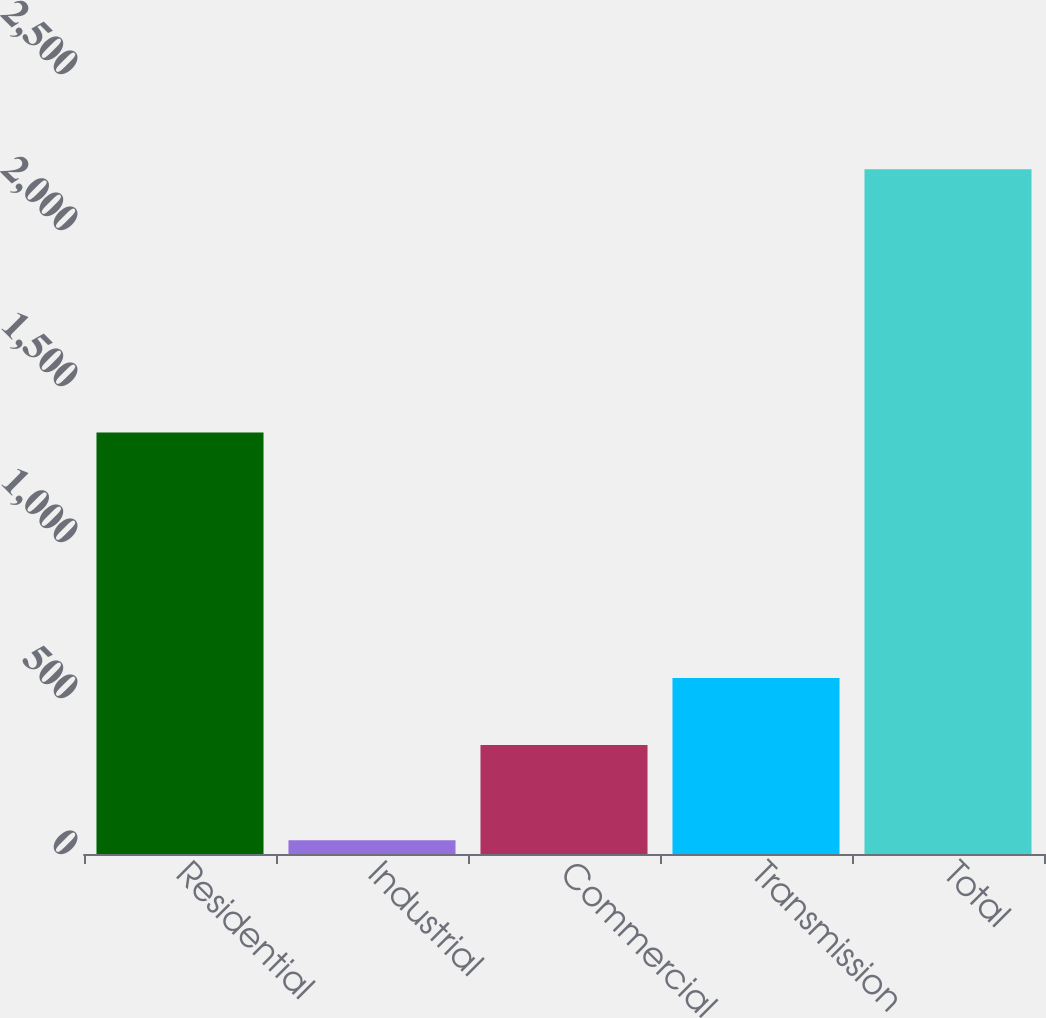Convert chart to OTSL. <chart><loc_0><loc_0><loc_500><loc_500><bar_chart><fcel>Residential<fcel>Industrial<fcel>Commercial<fcel>Transmission<fcel>Total<nl><fcel>1351<fcel>44<fcel>349<fcel>564.1<fcel>2195<nl></chart> 